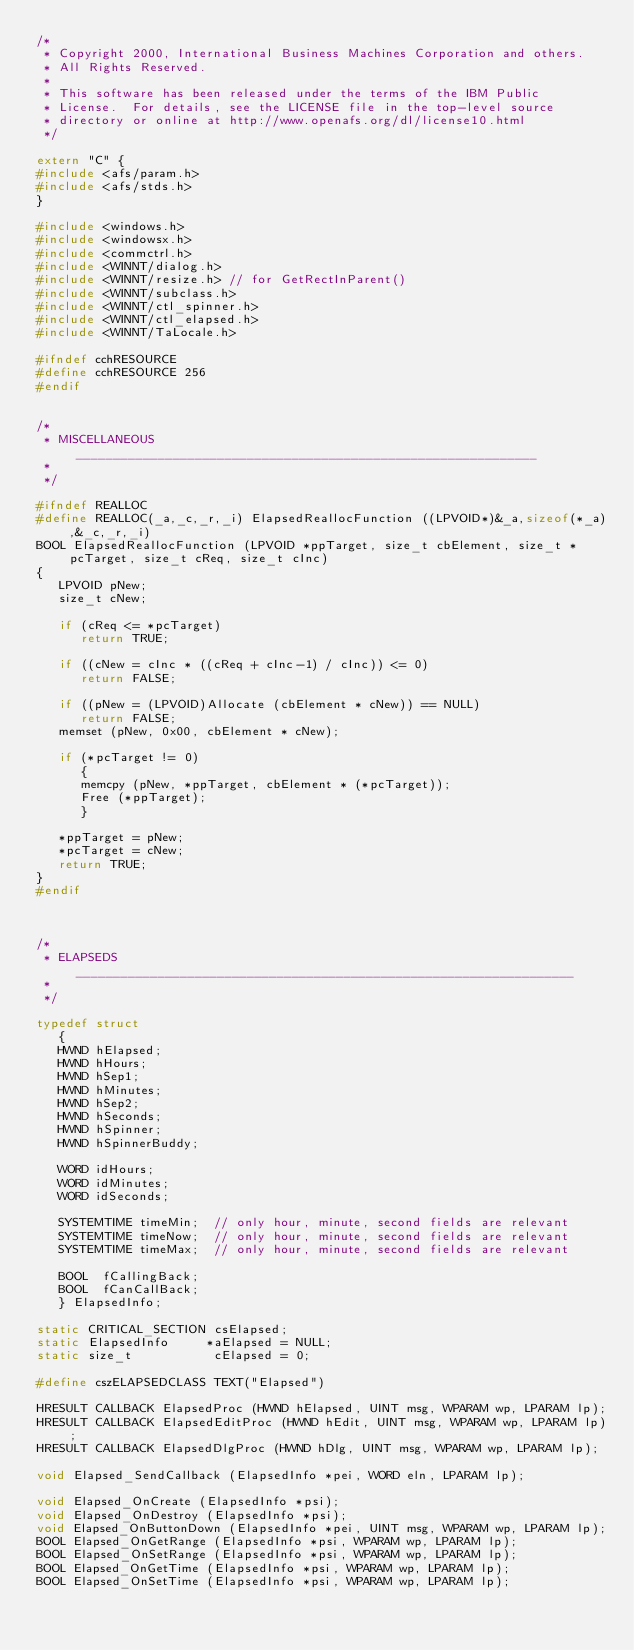<code> <loc_0><loc_0><loc_500><loc_500><_C++_>/*
 * Copyright 2000, International Business Machines Corporation and others.
 * All Rights Reserved.
 *
 * This software has been released under the terms of the IBM Public
 * License.  For details, see the LICENSE file in the top-level source
 * directory or online at http://www.openafs.org/dl/license10.html
 */

extern "C" {
#include <afs/param.h>
#include <afs/stds.h>
}

#include <windows.h>
#include <windowsx.h>
#include <commctrl.h>
#include <WINNT/dialog.h>
#include <WINNT/resize.h>	// for GetRectInParent()
#include <WINNT/subclass.h>
#include <WINNT/ctl_spinner.h>
#include <WINNT/ctl_elapsed.h>
#include <WINNT/TaLocale.h>

#ifndef cchRESOURCE
#define cchRESOURCE 256
#endif


/*
 * MISCELLANEOUS ______________________________________________________________
 *
 */

#ifndef REALLOC
#define REALLOC(_a,_c,_r,_i) ElapsedReallocFunction ((LPVOID*)&_a,sizeof(*_a),&_c,_r,_i)
BOOL ElapsedReallocFunction (LPVOID *ppTarget, size_t cbElement, size_t *pcTarget, size_t cReq, size_t cInc)
{
   LPVOID pNew;
   size_t cNew;

   if (cReq <= *pcTarget)
      return TRUE;

   if ((cNew = cInc * ((cReq + cInc-1) / cInc)) <= 0)
      return FALSE;

   if ((pNew = (LPVOID)Allocate (cbElement * cNew)) == NULL)
      return FALSE;
   memset (pNew, 0x00, cbElement * cNew);

   if (*pcTarget != 0)
      {
      memcpy (pNew, *ppTarget, cbElement * (*pcTarget));
      Free (*ppTarget);
      }

   *ppTarget = pNew;
   *pcTarget = cNew;
   return TRUE;
}
#endif



/*
 * ELAPSEDS ___________________________________________________________________
 *
 */

typedef struct
   {
   HWND hElapsed;
   HWND hHours;
   HWND hSep1;
   HWND hMinutes;
   HWND hSep2;
   HWND hSeconds;
   HWND hSpinner;
   HWND hSpinnerBuddy;

   WORD idHours;
   WORD idMinutes;
   WORD idSeconds;

   SYSTEMTIME timeMin;  // only hour, minute, second fields are relevant
   SYSTEMTIME timeNow;  // only hour, minute, second fields are relevant
   SYSTEMTIME timeMax;  // only hour, minute, second fields are relevant

   BOOL  fCallingBack;
   BOOL  fCanCallBack;
   } ElapsedInfo;

static CRITICAL_SECTION csElapsed;
static ElapsedInfo     *aElapsed = NULL;
static size_t           cElapsed = 0;

#define cszELAPSEDCLASS TEXT("Elapsed")

HRESULT CALLBACK ElapsedProc (HWND hElapsed, UINT msg, WPARAM wp, LPARAM lp);
HRESULT CALLBACK ElapsedEditProc (HWND hEdit, UINT msg, WPARAM wp, LPARAM lp);
HRESULT CALLBACK ElapsedDlgProc (HWND hDlg, UINT msg, WPARAM wp, LPARAM lp);

void Elapsed_SendCallback (ElapsedInfo *pei, WORD eln, LPARAM lp);

void Elapsed_OnCreate (ElapsedInfo *psi);
void Elapsed_OnDestroy (ElapsedInfo *psi);
void Elapsed_OnButtonDown (ElapsedInfo *pei, UINT msg, WPARAM wp, LPARAM lp);
BOOL Elapsed_OnGetRange (ElapsedInfo *psi, WPARAM wp, LPARAM lp);
BOOL Elapsed_OnSetRange (ElapsedInfo *psi, WPARAM wp, LPARAM lp);
BOOL Elapsed_OnGetTime (ElapsedInfo *psi, WPARAM wp, LPARAM lp);
BOOL Elapsed_OnSetTime (ElapsedInfo *psi, WPARAM wp, LPARAM lp);
</code> 